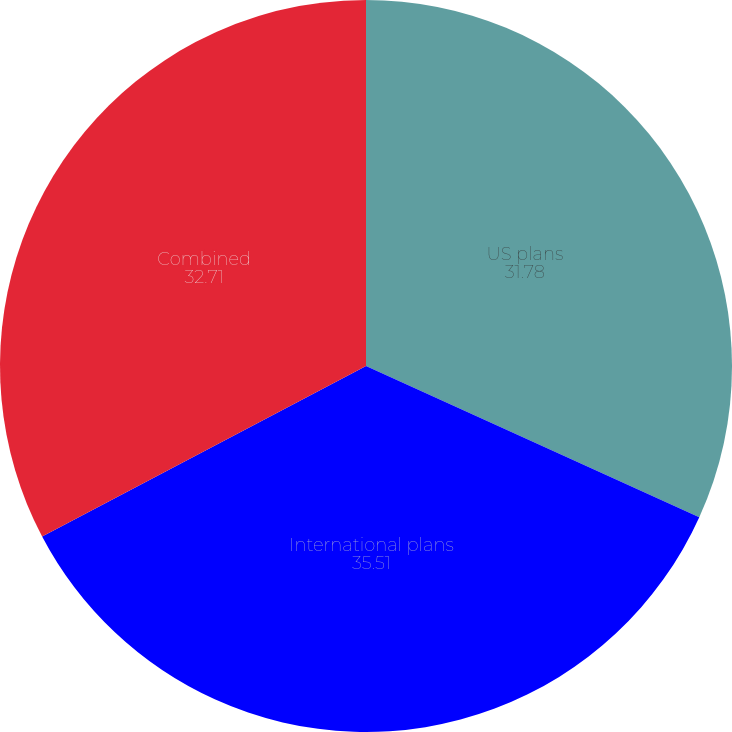Convert chart. <chart><loc_0><loc_0><loc_500><loc_500><pie_chart><fcel>US plans<fcel>International plans<fcel>Combined<nl><fcel>31.78%<fcel>35.51%<fcel>32.71%<nl></chart> 